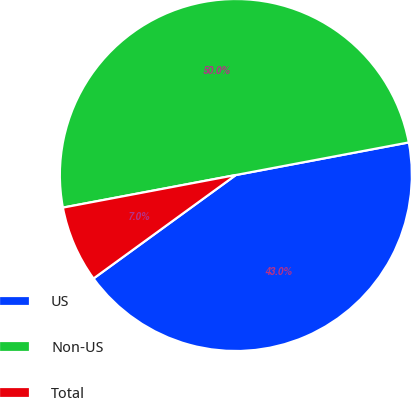Convert chart to OTSL. <chart><loc_0><loc_0><loc_500><loc_500><pie_chart><fcel>US<fcel>Non-US<fcel>Total<nl><fcel>42.96%<fcel>50.0%<fcel>7.04%<nl></chart> 